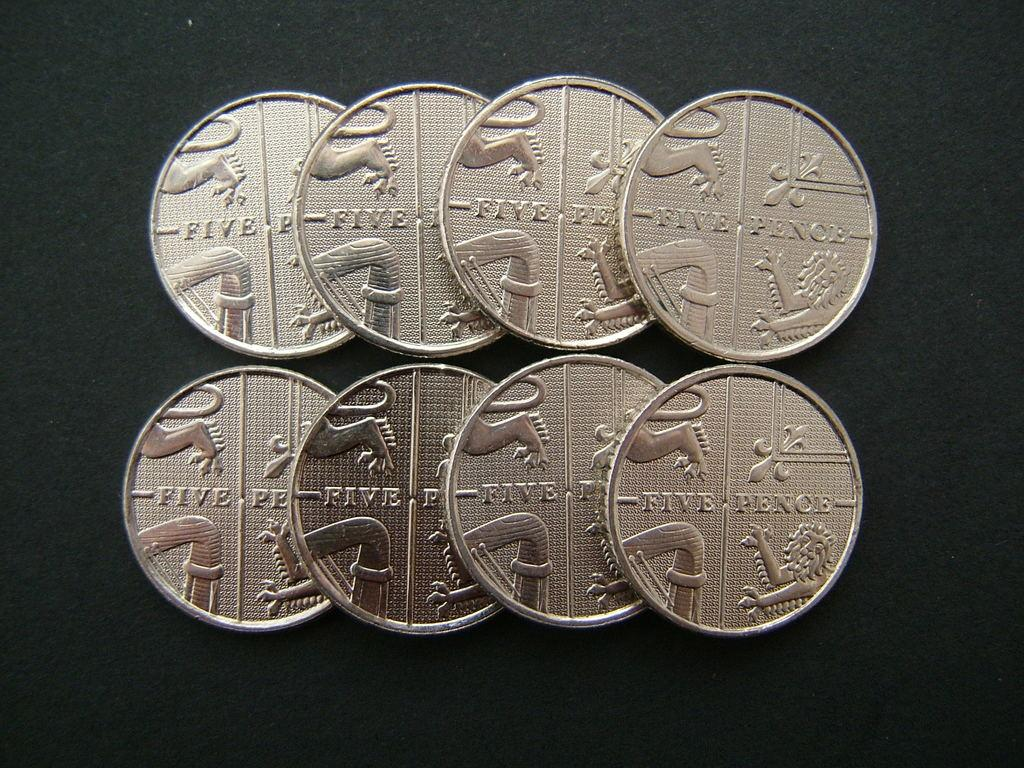<image>
Offer a succinct explanation of the picture presented. Eight five pence coins spread out on a dark surface 